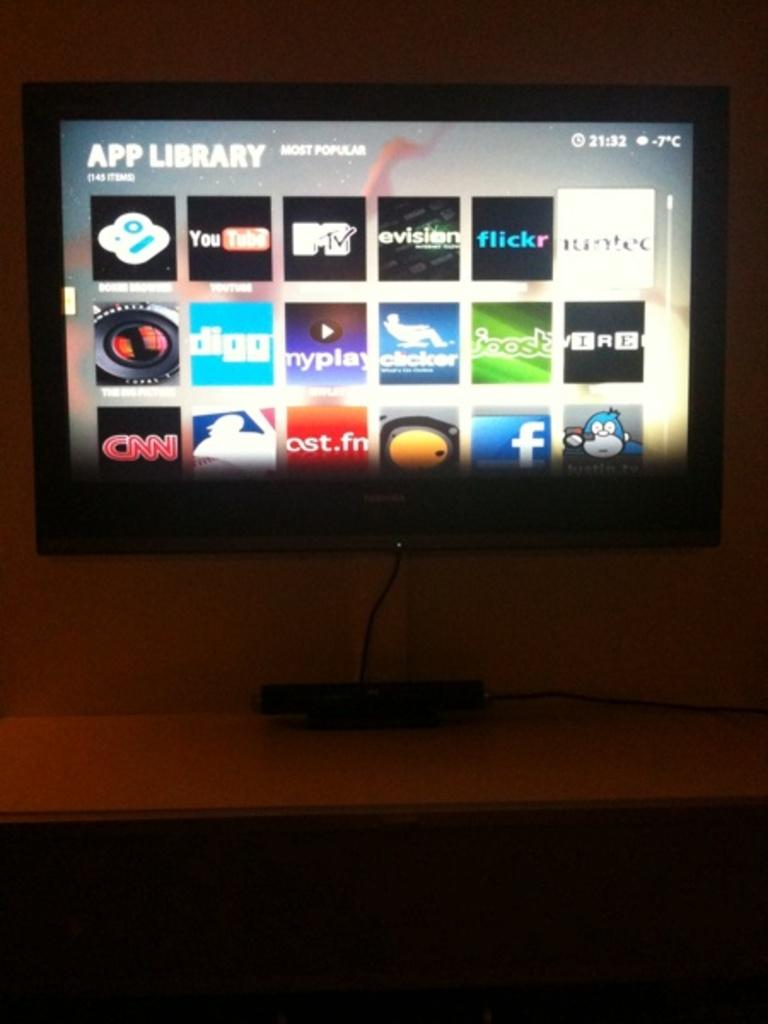<image>
Summarize the visual content of the image. A smart TV with the words APP LIBRARY at the top of the screen. 